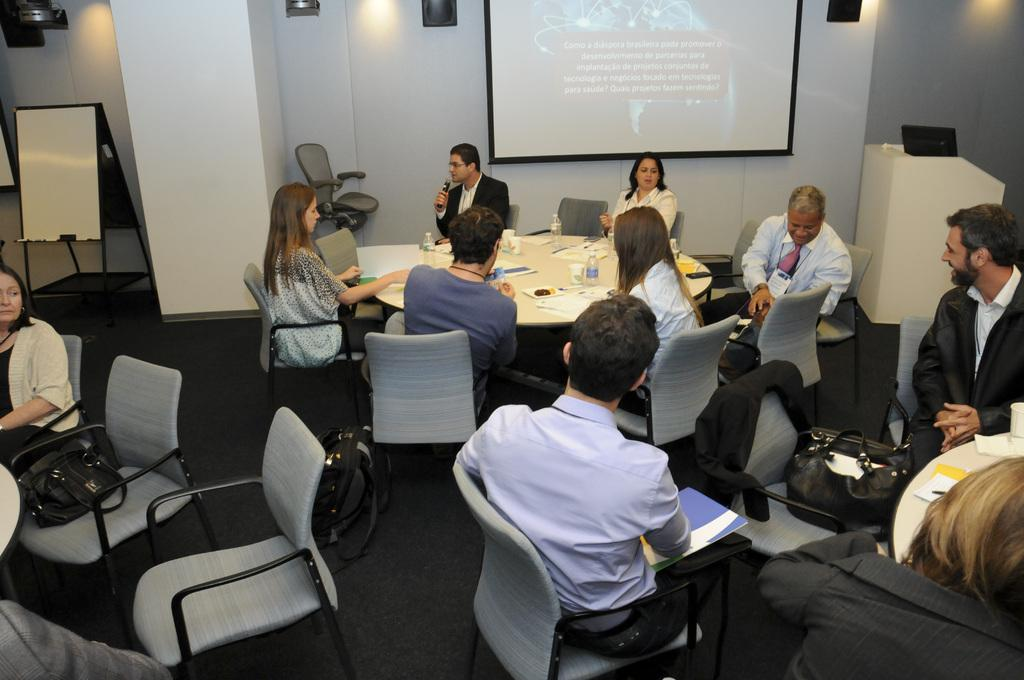How many people are in the group visible in the image? There is a group of persons in the image, but the exact number is not specified. What is the arrangement of the group in the image? The group of persons is sitting in front of a table. Can you describe the attire of one of the persons in the image? There is a person wearing a black suit in the image. What is the person wearing a black suit doing in the image? The person wearing a black suit is speaking in front of a mic. What is the position of the people sitting behind the person speaking? There are people sitting behind the person speaking. What type of sack is being used for the battle in the image? There is no battle or sack present in the image. Where is the lunchroom located in the image? The image does not depict a lunchroom or any indication of its location. 